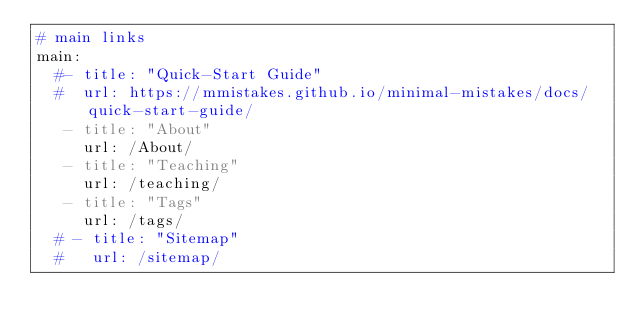Convert code to text. <code><loc_0><loc_0><loc_500><loc_500><_YAML_># main links
main:
  #- title: "Quick-Start Guide"
  #  url: https://mmistakes.github.io/minimal-mistakes/docs/quick-start-guide/
   - title: "About"
     url: /About/
   - title: "Teaching"
     url: /teaching/
   - title: "Tags"
     url: /tags/
  # - title: "Sitemap"
  #   url: /sitemap/</code> 